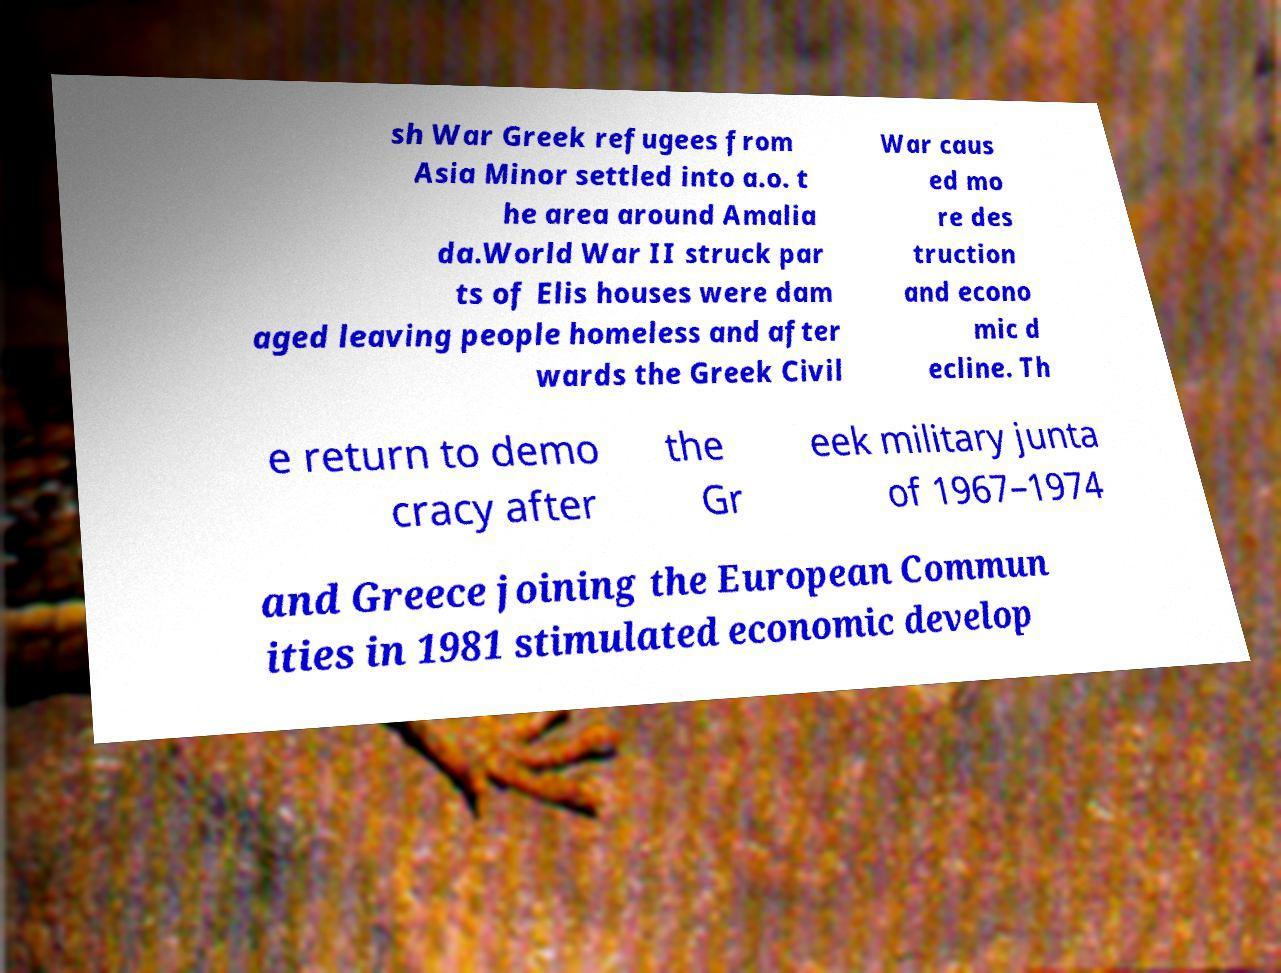There's text embedded in this image that I need extracted. Can you transcribe it verbatim? sh War Greek refugees from Asia Minor settled into a.o. t he area around Amalia da.World War II struck par ts of Elis houses were dam aged leaving people homeless and after wards the Greek Civil War caus ed mo re des truction and econo mic d ecline. Th e return to demo cracy after the Gr eek military junta of 1967–1974 and Greece joining the European Commun ities in 1981 stimulated economic develop 